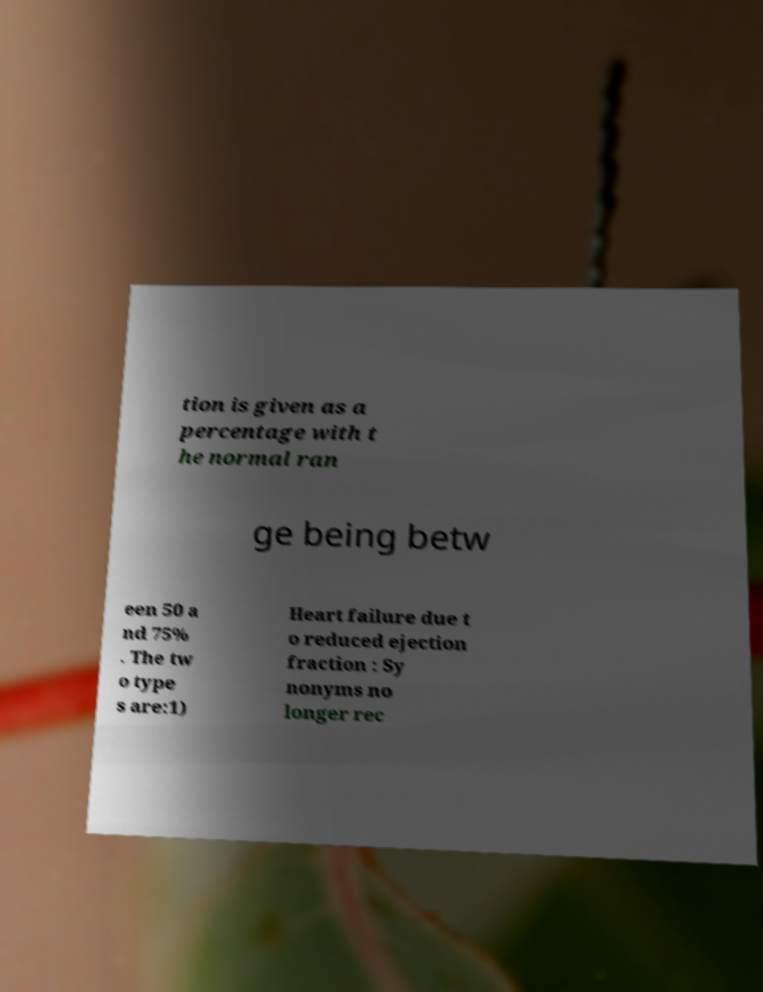Could you assist in decoding the text presented in this image and type it out clearly? tion is given as a percentage with t he normal ran ge being betw een 50 a nd 75% . The tw o type s are:1) Heart failure due t o reduced ejection fraction : Sy nonyms no longer rec 